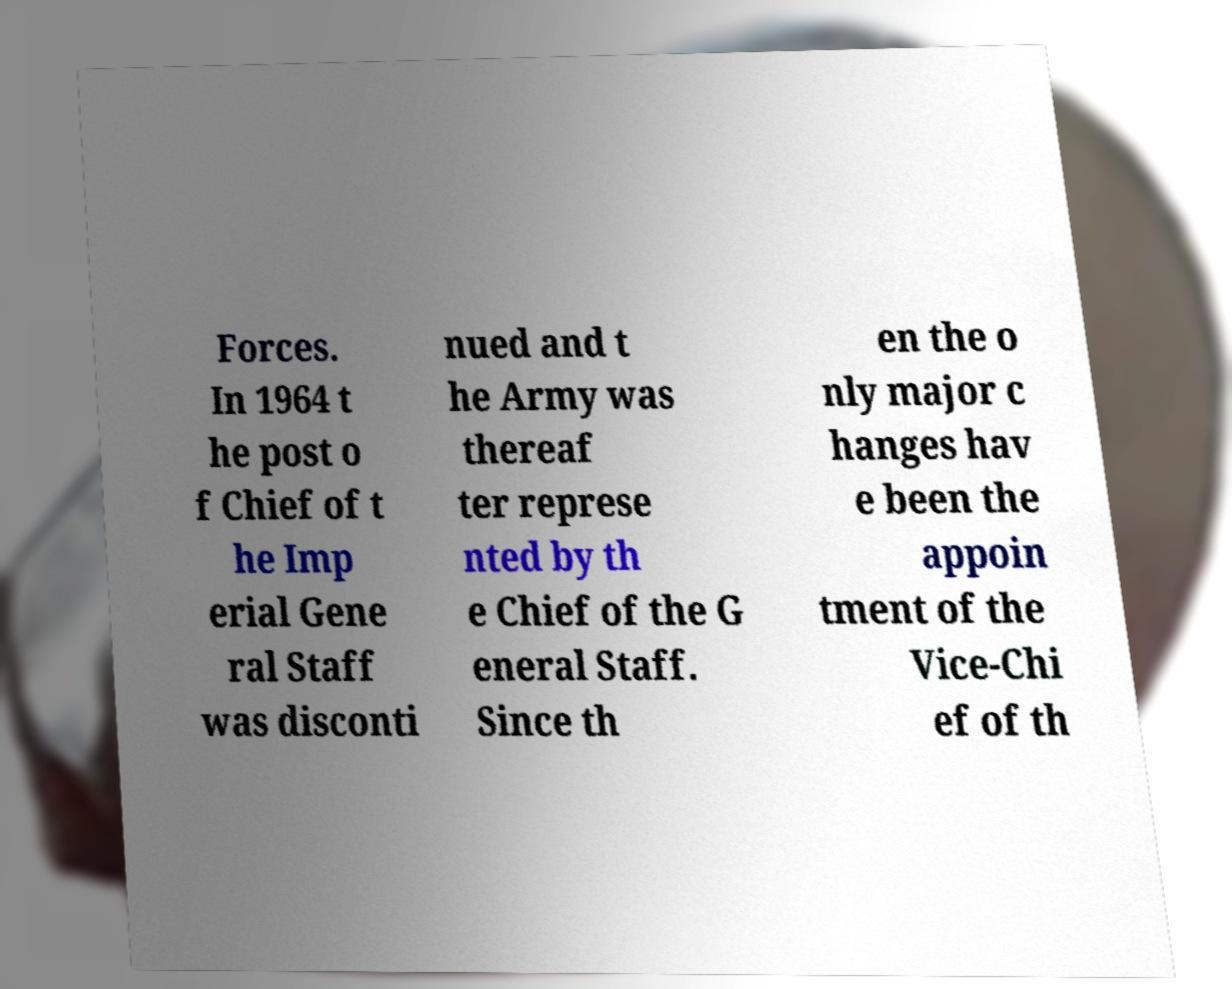I need the written content from this picture converted into text. Can you do that? Forces. In 1964 t he post o f Chief of t he Imp erial Gene ral Staff was disconti nued and t he Army was thereaf ter represe nted by th e Chief of the G eneral Staff. Since th en the o nly major c hanges hav e been the appoin tment of the Vice-Chi ef of th 